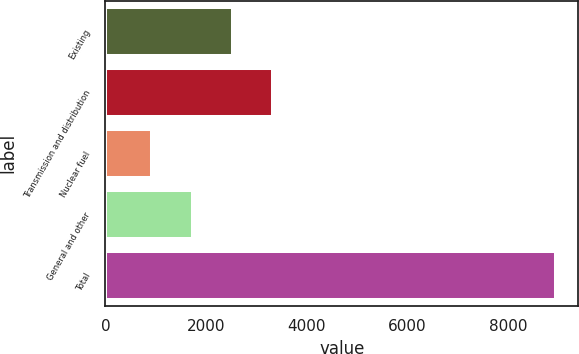Convert chart. <chart><loc_0><loc_0><loc_500><loc_500><bar_chart><fcel>Existing<fcel>Transmission and distribution<fcel>Nuclear fuel<fcel>General and other<fcel>Total<nl><fcel>2536<fcel>3336.5<fcel>935<fcel>1735.5<fcel>8940<nl></chart> 